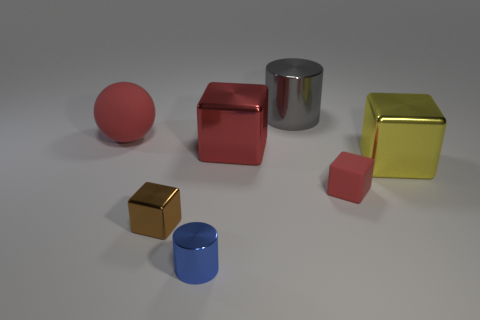Add 1 tiny things. How many objects exist? 8 Subtract all cubes. How many objects are left? 3 Add 4 gray cylinders. How many gray cylinders are left? 5 Add 1 big purple rubber balls. How many big purple rubber balls exist? 1 Subtract all red blocks. How many blocks are left? 2 Subtract all small brown cubes. How many cubes are left? 3 Subtract 0 cyan cylinders. How many objects are left? 7 Subtract 1 cylinders. How many cylinders are left? 1 Subtract all gray blocks. Subtract all brown spheres. How many blocks are left? 4 Subtract all yellow cylinders. How many yellow blocks are left? 1 